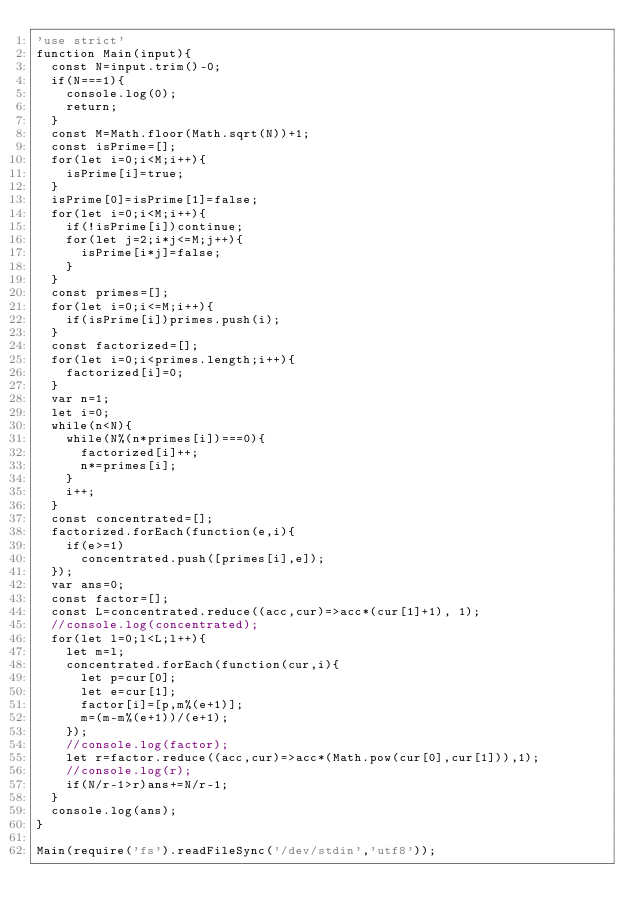Convert code to text. <code><loc_0><loc_0><loc_500><loc_500><_JavaScript_>'use strict'
function Main(input){
  const N=input.trim()-0;
  if(N===1){
    console.log(0);
    return;
  }
  const M=Math.floor(Math.sqrt(N))+1;
  const isPrime=[];
  for(let i=0;i<M;i++){
    isPrime[i]=true;
  }
  isPrime[0]=isPrime[1]=false;
  for(let i=0;i<M;i++){
    if(!isPrime[i])continue;
    for(let j=2;i*j<=M;j++){
      isPrime[i*j]=false;
    }
  }
  const primes=[];
  for(let i=0;i<=M;i++){
    if(isPrime[i])primes.push(i);
  }
  const factorized=[];
  for(let i=0;i<primes.length;i++){
    factorized[i]=0;
  }
  var n=1;
  let i=0;
  while(n<N){
    while(N%(n*primes[i])===0){
      factorized[i]++;
      n*=primes[i];
    }
    i++;
  }
  const concentrated=[];
  factorized.forEach(function(e,i){
    if(e>=1)
      concentrated.push([primes[i],e]);
  });
  var ans=0;
  const factor=[];
  const L=concentrated.reduce((acc,cur)=>acc*(cur[1]+1), 1);
  //console.log(concentrated);
  for(let l=0;l<L;l++){
    let m=l;
    concentrated.forEach(function(cur,i){
      let p=cur[0];
      let e=cur[1];
      factor[i]=[p,m%(e+1)];
      m=(m-m%(e+1))/(e+1);
    });
    //console.log(factor);
    let r=factor.reduce((acc,cur)=>acc*(Math.pow(cur[0],cur[1])),1);
    //console.log(r);
    if(N/r-1>r)ans+=N/r-1;
  }
  console.log(ans);
}

Main(require('fs').readFileSync('/dev/stdin','utf8'));
</code> 